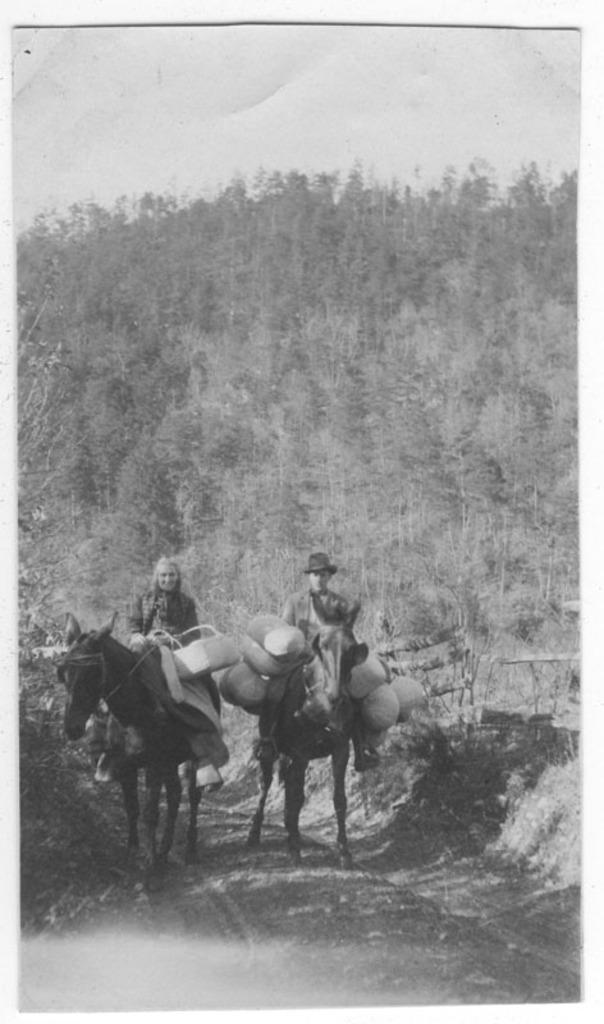What are the two people in the image doing? There are two people riding horses in the image. Can you describe the riders? One of the riders is a man, and the other is a woman. What are the riders carrying with them? The riders have luggage with them. What can be seen in the background of the image? There are trees and the sky visible in the background of the image. What type of wool is being used to create the beam in the image? There is no wool or beam present in the image; it features two people riding horses with luggage. 